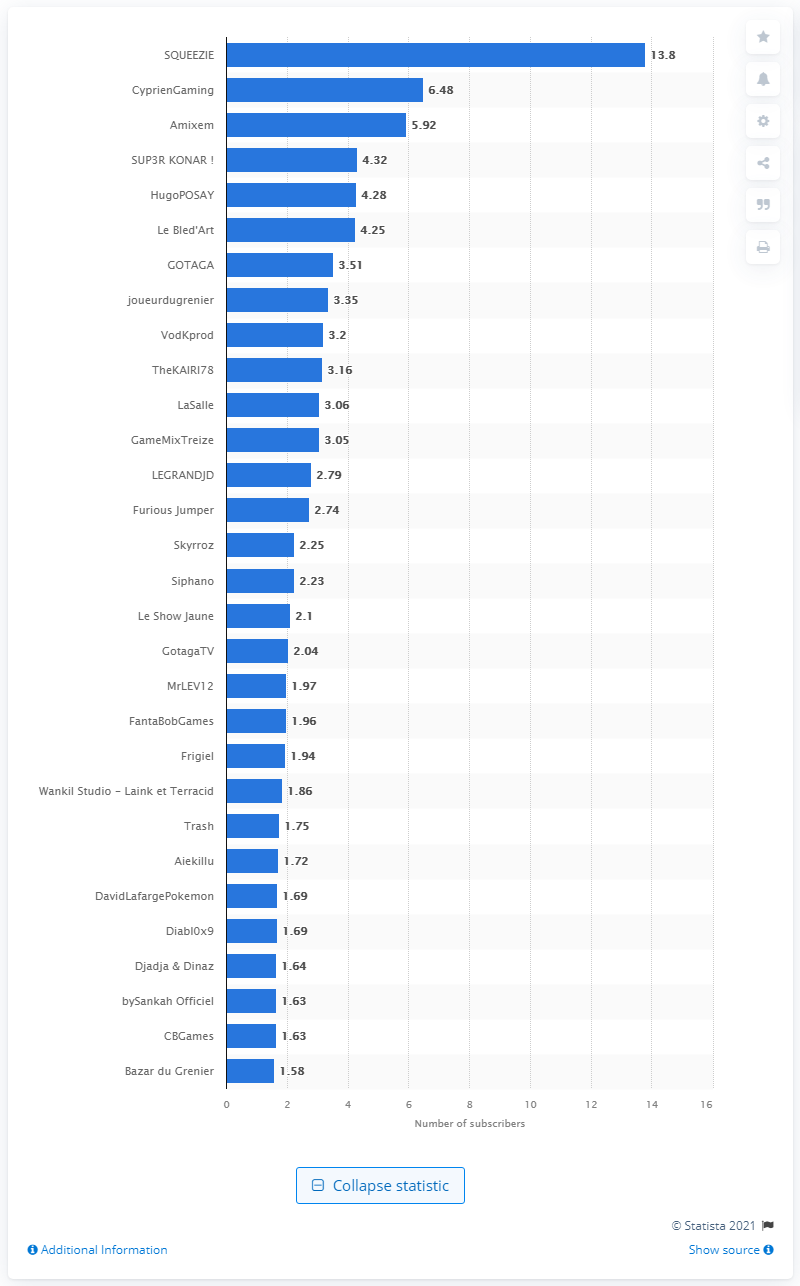Outline some significant characteristics in this image. In November 2019, Squeezie had 13.8 subscribers. 